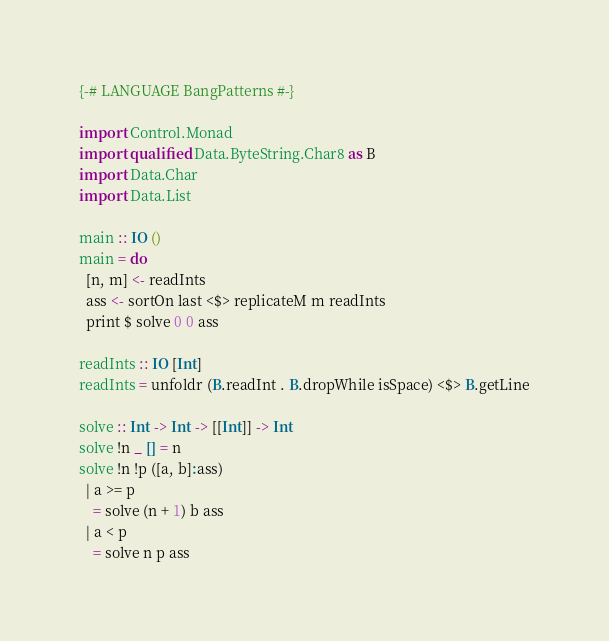<code> <loc_0><loc_0><loc_500><loc_500><_Haskell_>{-# LANGUAGE BangPatterns #-}

import Control.Monad
import qualified Data.ByteString.Char8 as B
import Data.Char
import Data.List

main :: IO ()
main = do
  [n, m] <- readInts
  ass <- sortOn last <$> replicateM m readInts
  print $ solve 0 0 ass

readInts :: IO [Int]
readInts = unfoldr (B.readInt . B.dropWhile isSpace) <$> B.getLine

solve :: Int -> Int -> [[Int]] -> Int
solve !n _ [] = n
solve !n !p ([a, b]:ass)
  | a >= p
    = solve (n + 1) b ass
  | a < p
    = solve n p ass
</code> 